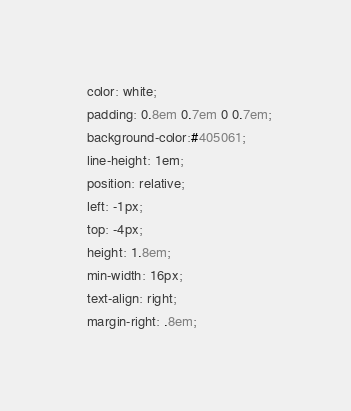<code> <loc_0><loc_0><loc_500><loc_500><_CSS_>  color: white;
  padding: 0.8em 0.7em 0 0.7em;
  background-color:#405061;
  line-height: 1em;
  position: relative;
  left: -1px;
  top: -4px;
  height: 1.8em;
  min-width: 16px;
  text-align: right;
  margin-right: .8em;</code> 